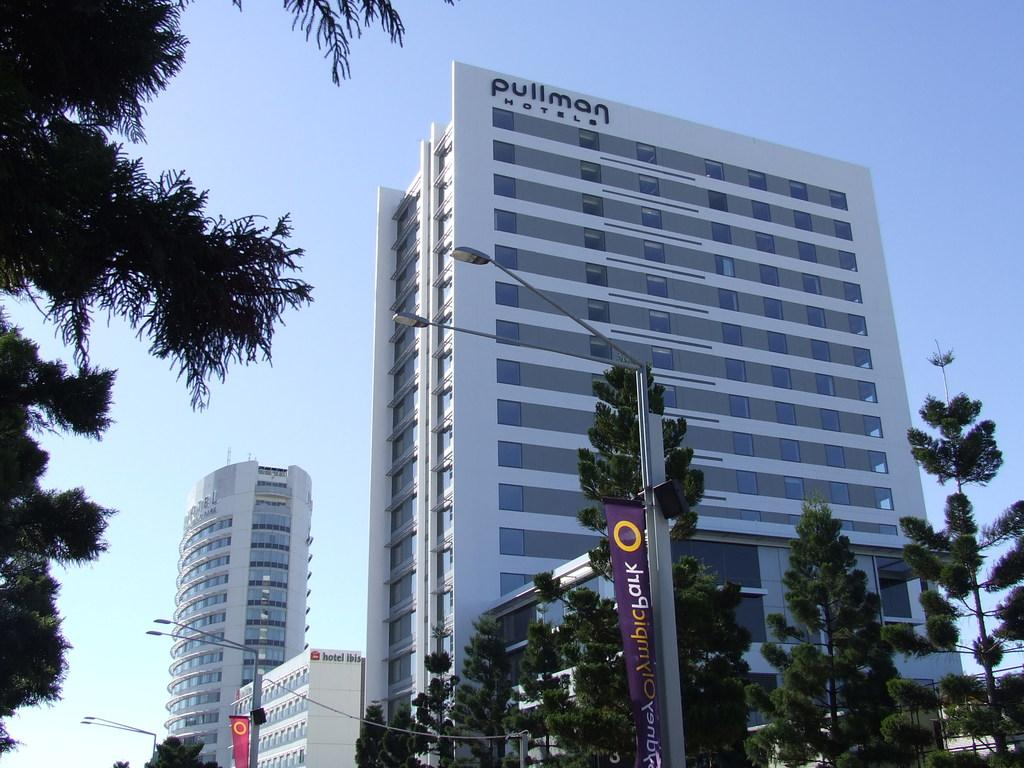What type of structures can be seen in the image? There are buildings in the image. What other objects can be seen in the image besides buildings? There are trees and poles in the image. What can be seen in the background of the image? The sky is visible in the background of the image. What type of jeans is the minister wearing in the image? There is no minister or jeans present in the image. 